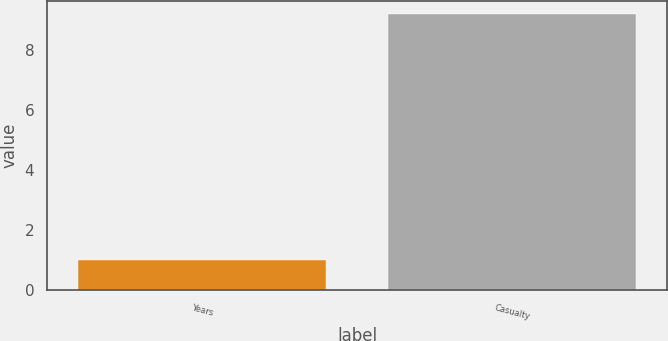<chart> <loc_0><loc_0><loc_500><loc_500><bar_chart><fcel>Years<fcel>Casualty<nl><fcel>1<fcel>9.2<nl></chart> 